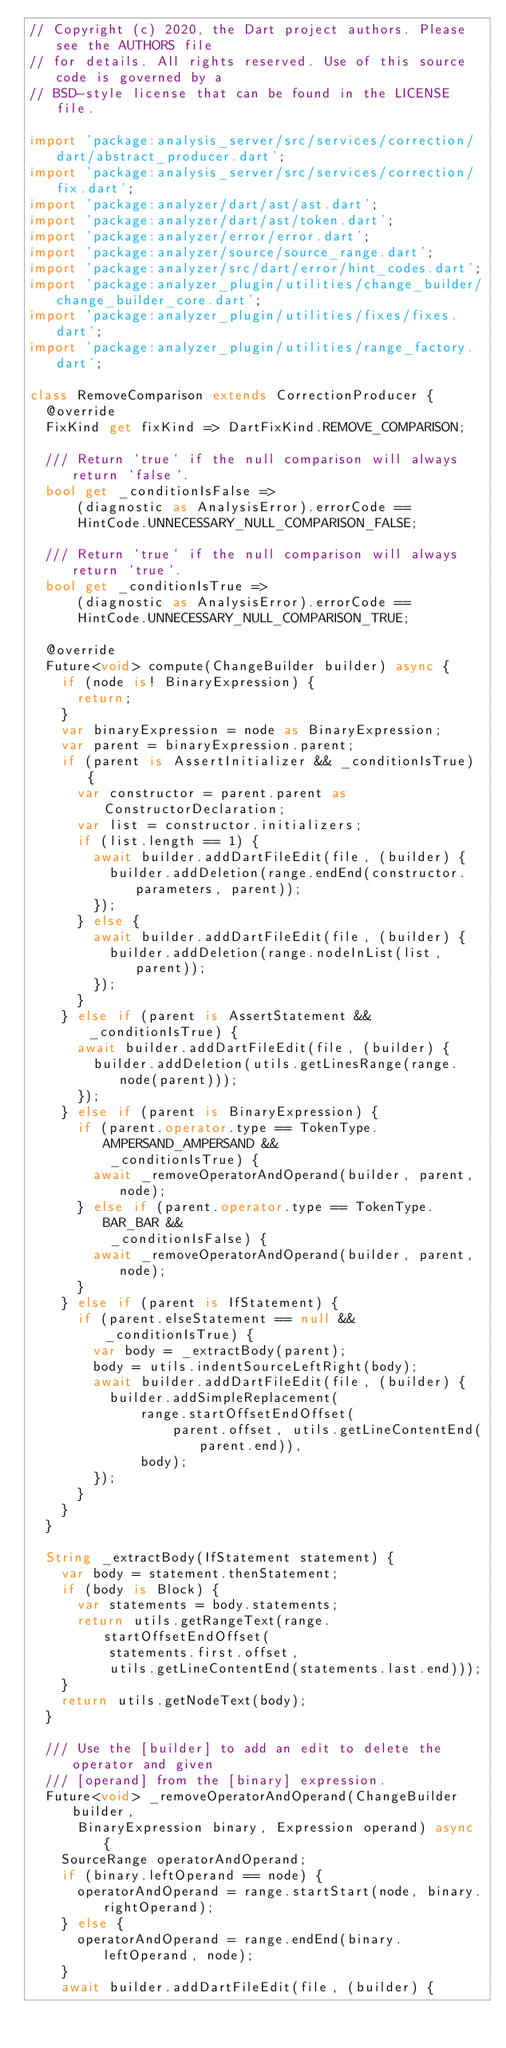<code> <loc_0><loc_0><loc_500><loc_500><_Dart_>// Copyright (c) 2020, the Dart project authors. Please see the AUTHORS file
// for details. All rights reserved. Use of this source code is governed by a
// BSD-style license that can be found in the LICENSE file.

import 'package:analysis_server/src/services/correction/dart/abstract_producer.dart';
import 'package:analysis_server/src/services/correction/fix.dart';
import 'package:analyzer/dart/ast/ast.dart';
import 'package:analyzer/dart/ast/token.dart';
import 'package:analyzer/error/error.dart';
import 'package:analyzer/source/source_range.dart';
import 'package:analyzer/src/dart/error/hint_codes.dart';
import 'package:analyzer_plugin/utilities/change_builder/change_builder_core.dart';
import 'package:analyzer_plugin/utilities/fixes/fixes.dart';
import 'package:analyzer_plugin/utilities/range_factory.dart';

class RemoveComparison extends CorrectionProducer {
  @override
  FixKind get fixKind => DartFixKind.REMOVE_COMPARISON;

  /// Return `true` if the null comparison will always return `false`.
  bool get _conditionIsFalse =>
      (diagnostic as AnalysisError).errorCode ==
      HintCode.UNNECESSARY_NULL_COMPARISON_FALSE;

  /// Return `true` if the null comparison will always return `true`.
  bool get _conditionIsTrue =>
      (diagnostic as AnalysisError).errorCode ==
      HintCode.UNNECESSARY_NULL_COMPARISON_TRUE;

  @override
  Future<void> compute(ChangeBuilder builder) async {
    if (node is! BinaryExpression) {
      return;
    }
    var binaryExpression = node as BinaryExpression;
    var parent = binaryExpression.parent;
    if (parent is AssertInitializer && _conditionIsTrue) {
      var constructor = parent.parent as ConstructorDeclaration;
      var list = constructor.initializers;
      if (list.length == 1) {
        await builder.addDartFileEdit(file, (builder) {
          builder.addDeletion(range.endEnd(constructor.parameters, parent));
        });
      } else {
        await builder.addDartFileEdit(file, (builder) {
          builder.addDeletion(range.nodeInList(list, parent));
        });
      }
    } else if (parent is AssertStatement && _conditionIsTrue) {
      await builder.addDartFileEdit(file, (builder) {
        builder.addDeletion(utils.getLinesRange(range.node(parent)));
      });
    } else if (parent is BinaryExpression) {
      if (parent.operator.type == TokenType.AMPERSAND_AMPERSAND &&
          _conditionIsTrue) {
        await _removeOperatorAndOperand(builder, parent, node);
      } else if (parent.operator.type == TokenType.BAR_BAR &&
          _conditionIsFalse) {
        await _removeOperatorAndOperand(builder, parent, node);
      }
    } else if (parent is IfStatement) {
      if (parent.elseStatement == null && _conditionIsTrue) {
        var body = _extractBody(parent);
        body = utils.indentSourceLeftRight(body);
        await builder.addDartFileEdit(file, (builder) {
          builder.addSimpleReplacement(
              range.startOffsetEndOffset(
                  parent.offset, utils.getLineContentEnd(parent.end)),
              body);
        });
      }
    }
  }

  String _extractBody(IfStatement statement) {
    var body = statement.thenStatement;
    if (body is Block) {
      var statements = body.statements;
      return utils.getRangeText(range.startOffsetEndOffset(
          statements.first.offset,
          utils.getLineContentEnd(statements.last.end)));
    }
    return utils.getNodeText(body);
  }

  /// Use the [builder] to add an edit to delete the operator and given
  /// [operand] from the [binary] expression.
  Future<void> _removeOperatorAndOperand(ChangeBuilder builder,
      BinaryExpression binary, Expression operand) async {
    SourceRange operatorAndOperand;
    if (binary.leftOperand == node) {
      operatorAndOperand = range.startStart(node, binary.rightOperand);
    } else {
      operatorAndOperand = range.endEnd(binary.leftOperand, node);
    }
    await builder.addDartFileEdit(file, (builder) {</code> 